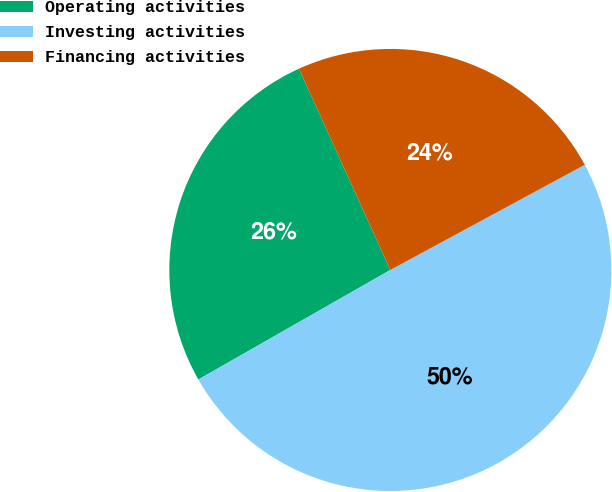<chart> <loc_0><loc_0><loc_500><loc_500><pie_chart><fcel>Operating activities<fcel>Investing activities<fcel>Financing activities<nl><fcel>26.47%<fcel>49.64%<fcel>23.89%<nl></chart> 